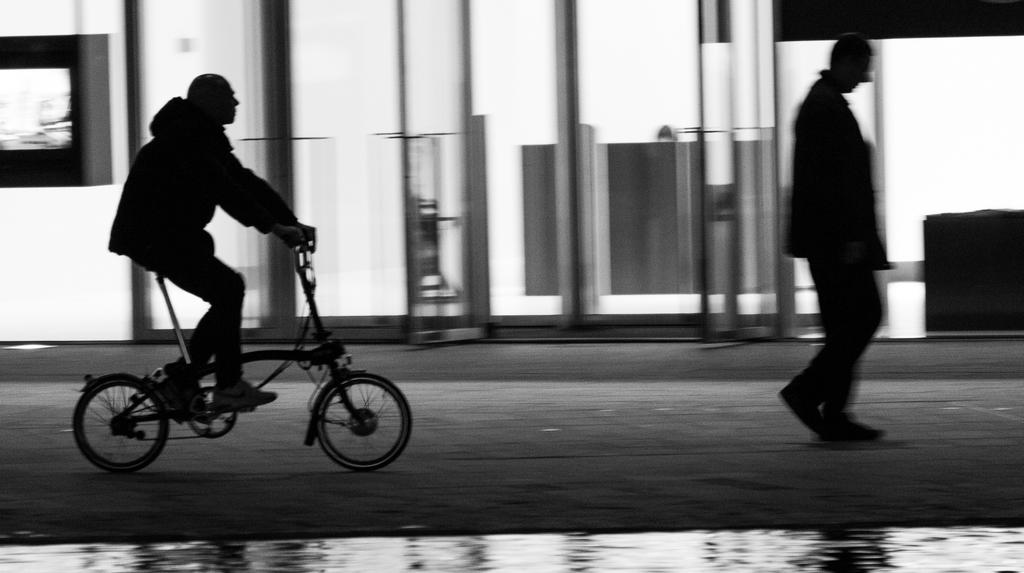What is the main subject of the image? There is a person riding a bicycle in the image. Are there any other people in the image? Yes, there is another person walking in the image. What can be seen in the background of the image? There is a building in the background of the image. What type of error can be seen in the person's shirt in the image? There is no person's shirt visible in the image, and therefore no errors can be observed. What type of drug is the person on the bicycle taking in the image? There is no indication in the image that the person is taking any drugs, so it cannot be determined from the picture. 